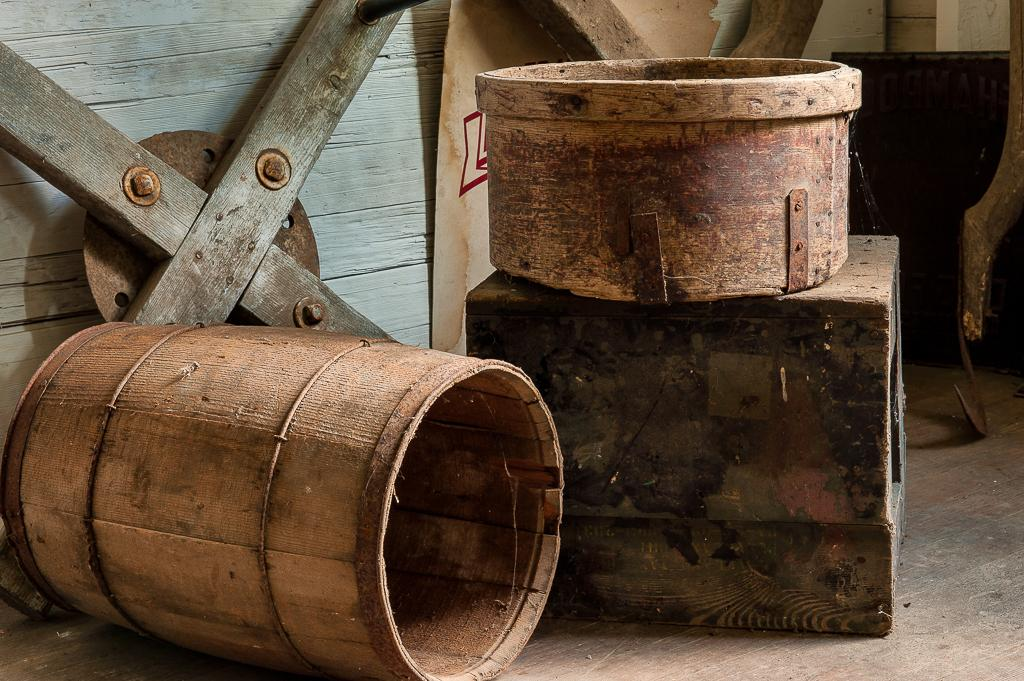What type of container is in the image? There is a wooden barrel in the image. What other type of container is in the image? There is a box in the image. What material are the other objects in the image made of? The other objects in the image are also made of wood. Where are all the mentioned objects located in the image? All the mentioned objects are on the floor. What type of fruit is hanging from the clouds in the image? There are no clouds or fruit present in the image. What type of scale is used to weigh the wooden objects in the image? There is no scale present in the image; it only features wooden objects on the floor. 